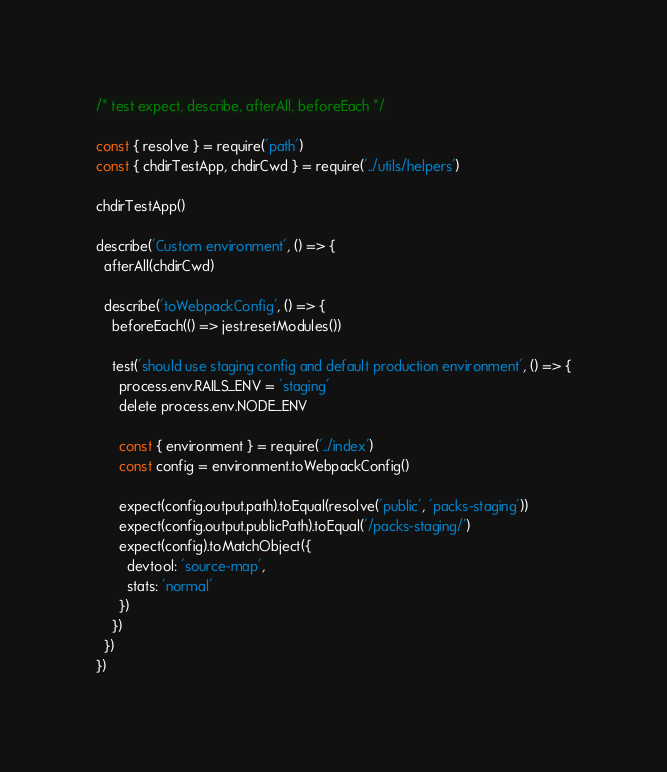<code> <loc_0><loc_0><loc_500><loc_500><_JavaScript_>/* test expect, describe, afterAll, beforeEach */

const { resolve } = require('path')
const { chdirTestApp, chdirCwd } = require('../utils/helpers')

chdirTestApp()

describe('Custom environment', () => {
  afterAll(chdirCwd)

  describe('toWebpackConfig', () => {
    beforeEach(() => jest.resetModules())

    test('should use staging config and default production environment', () => {
      process.env.RAILS_ENV = 'staging'
      delete process.env.NODE_ENV

      const { environment } = require('../index')
      const config = environment.toWebpackConfig()

      expect(config.output.path).toEqual(resolve('public', 'packs-staging'))
      expect(config.output.publicPath).toEqual('/packs-staging/')
      expect(config).toMatchObject({
        devtool: 'source-map',
        stats: 'normal'
      })
    })
  })
})
</code> 